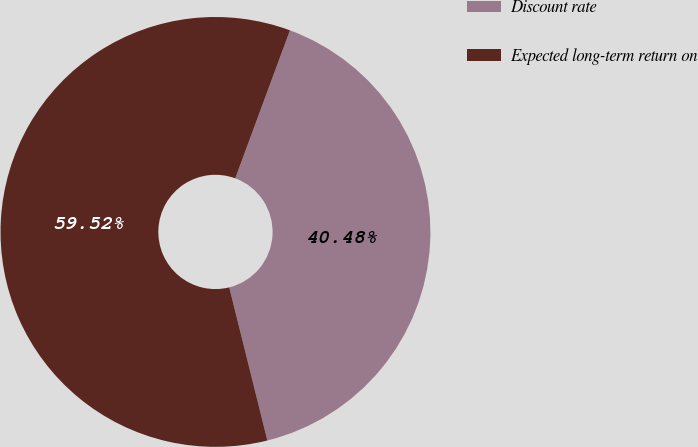Convert chart. <chart><loc_0><loc_0><loc_500><loc_500><pie_chart><fcel>Discount rate<fcel>Expected long-term return on<nl><fcel>40.48%<fcel>59.52%<nl></chart> 